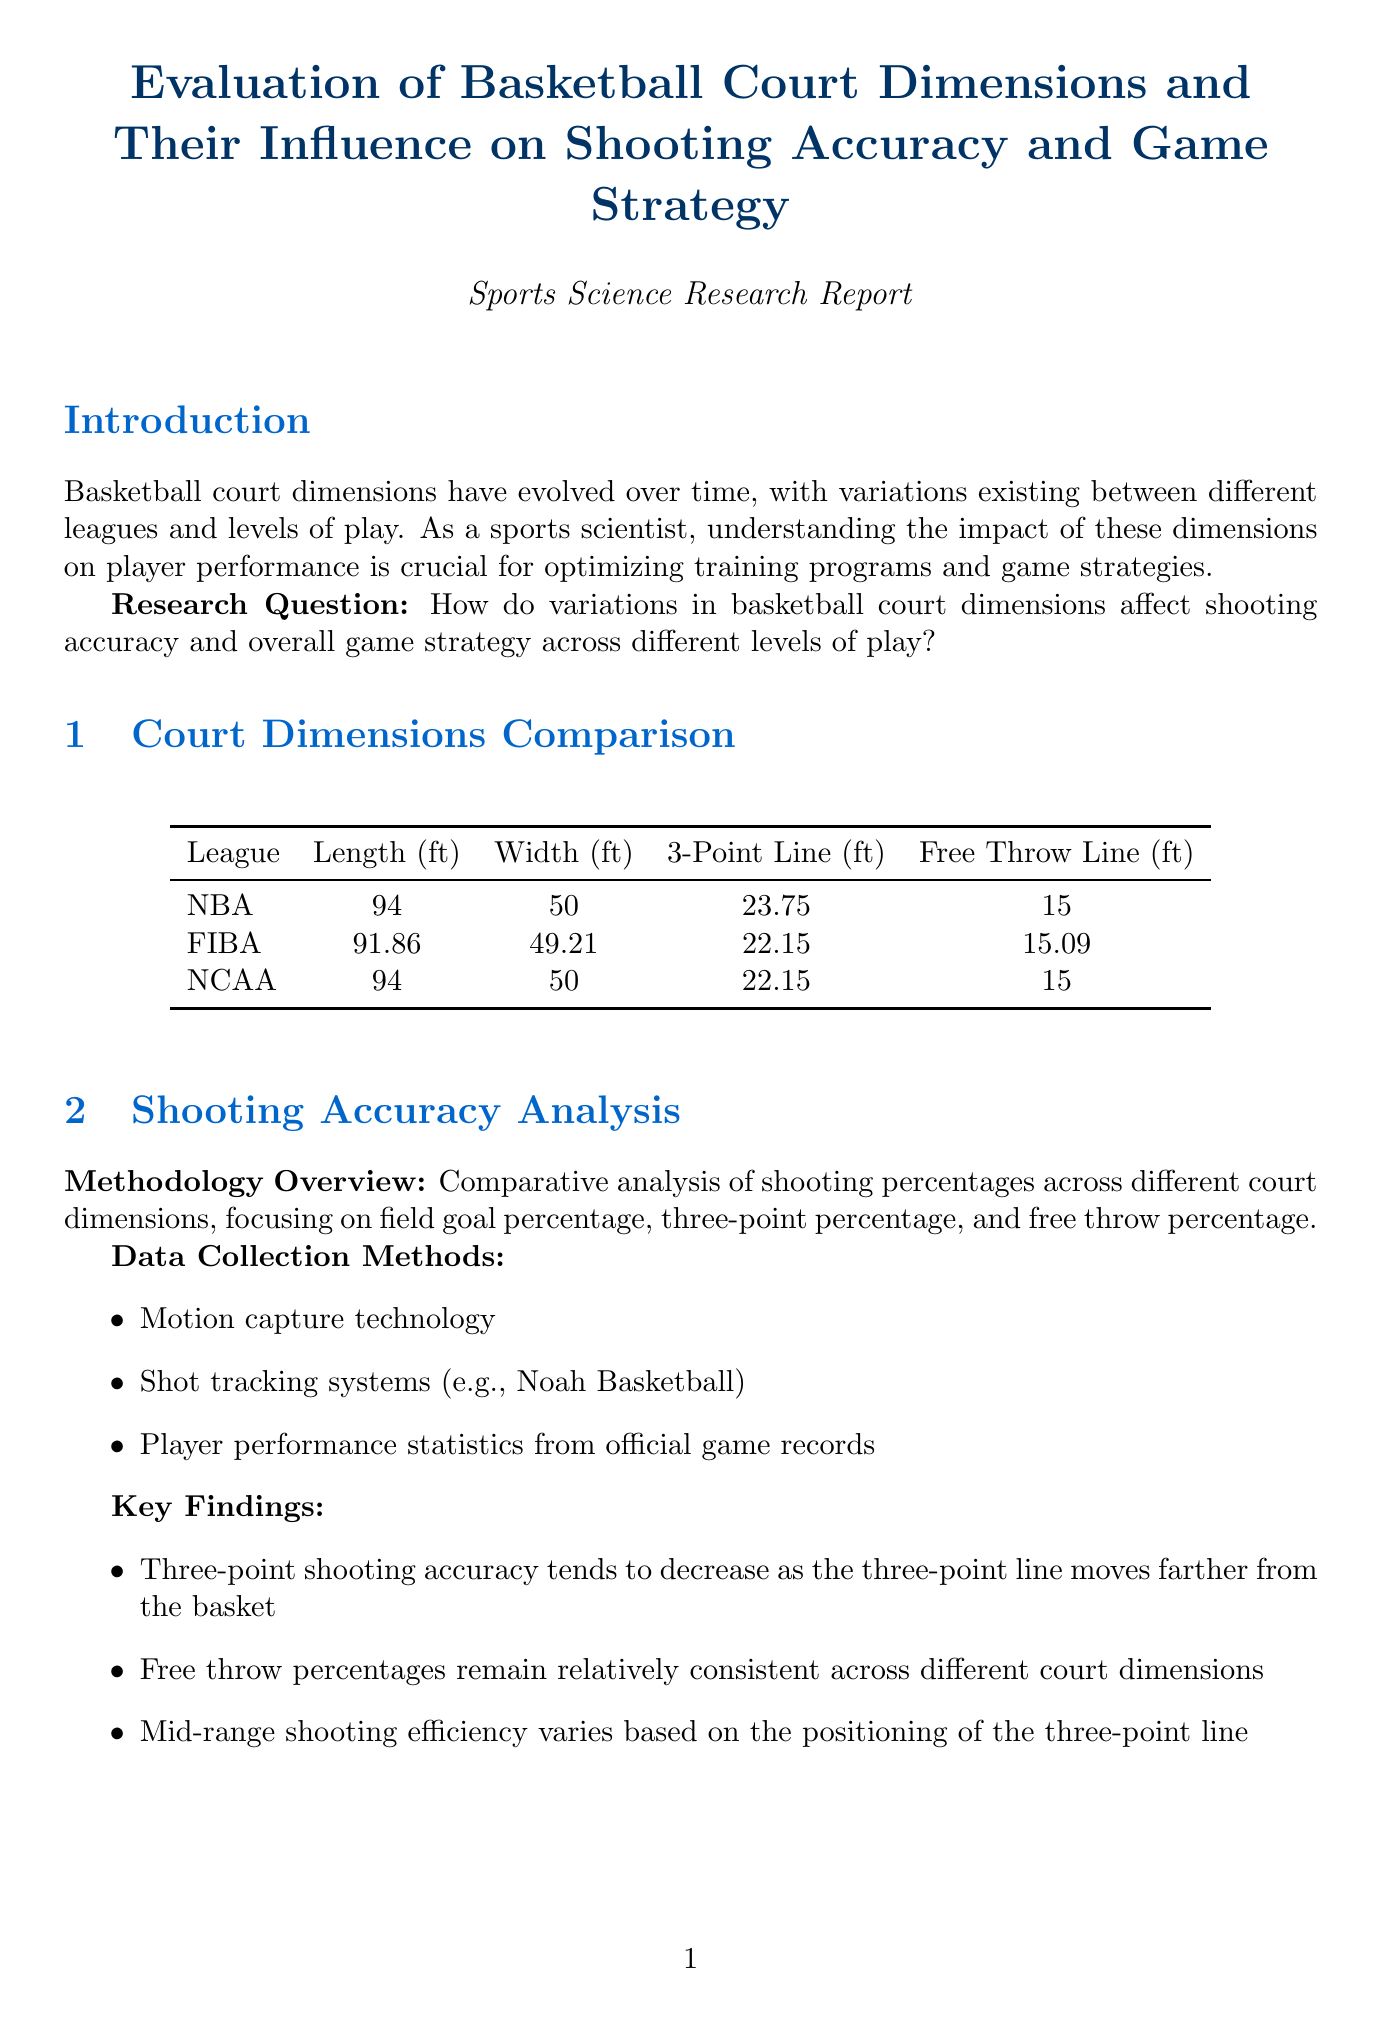what is the length of an NBA court? The document states the length of an NBA court is 94 feet.
Answer: 94 feet what is the three-point line distance in FIBA? According to the document, the three-point line distance in FIBA is 22.15 feet.
Answer: 22.15 feet how does three-point shooting accuracy change with court dimensions? The document mentions that three-point shooting accuracy tends to decrease as the three-point line moves farther from the basket.
Answer: Decrease what was a key outcome of the FIBA World Cup Performance Comparison? The analysis found a key outcome of higher three-point shooting percentages in FIBA games.
Answer: Higher three-point shooting percentages what recommendation is made for training facilities? The report recommends implementing variable court dimensions in training facilities to improve player adaptability.
Answer: Variable court dimensions how much distance do players cover on average in NBA dimensions? The document states players cover an average of 2.5 miles per game in NBA dimensions.
Answer: 2.5 miles what is the free throw line distance in NCAA basketball? The document indicates that the free throw line distance in NCAA basketball is 15 feet.
Answer: 15 feet what adjustment do players need when transitioning between different court dimensions? The document explains that players require different release angles and power when transitioning between court dimensions.
Answer: Different release angles and power 